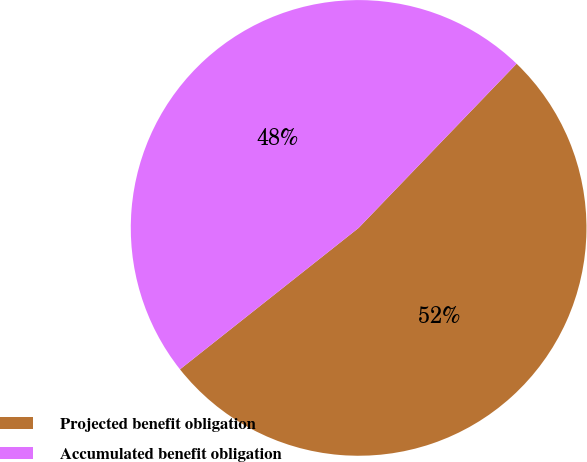<chart> <loc_0><loc_0><loc_500><loc_500><pie_chart><fcel>Projected benefit obligation<fcel>Accumulated benefit obligation<nl><fcel>52.15%<fcel>47.85%<nl></chart> 